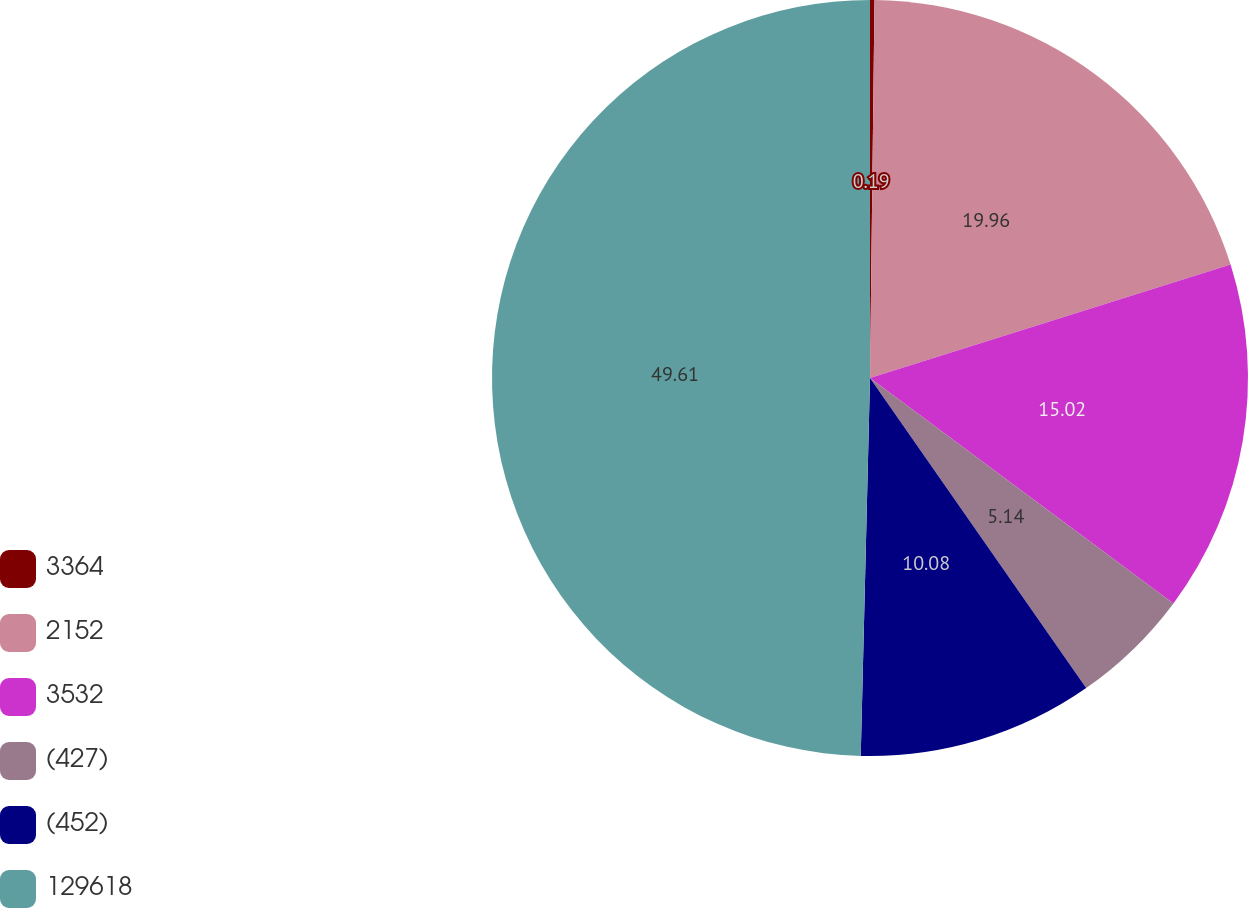Convert chart. <chart><loc_0><loc_0><loc_500><loc_500><pie_chart><fcel>3364<fcel>2152<fcel>3532<fcel>(427)<fcel>(452)<fcel>129618<nl><fcel>0.19%<fcel>19.96%<fcel>15.02%<fcel>5.14%<fcel>10.08%<fcel>49.61%<nl></chart> 